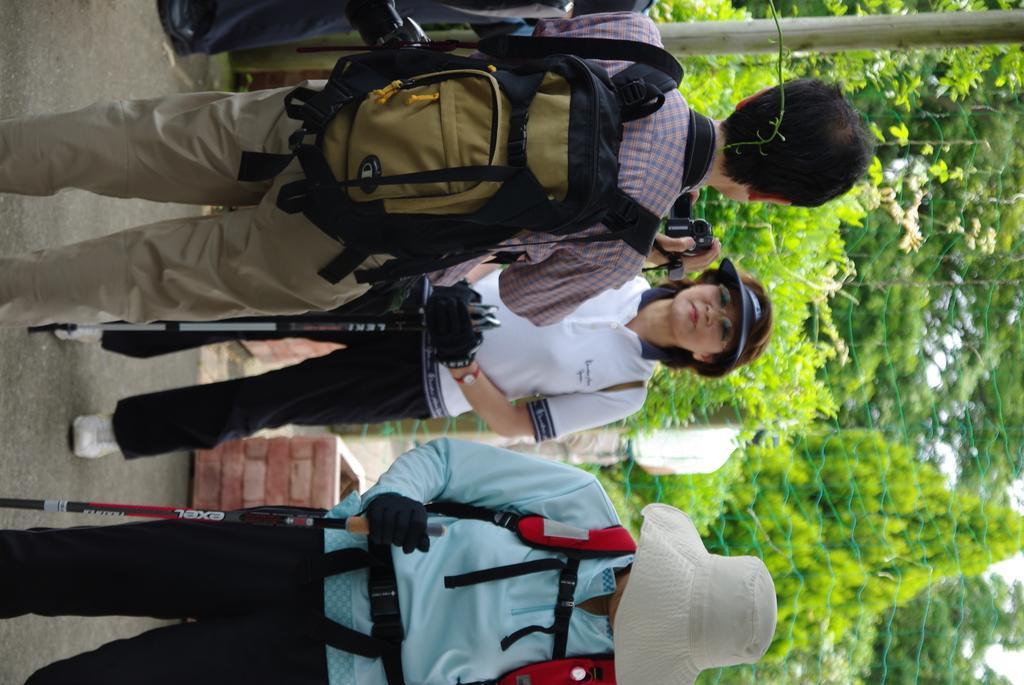Please provide a concise description of this image. In this image, we can see few peoples are standing. Few are smiling. Few are wearing a caps on his head. At the left side, person is wearing a backpack and he hold camera on his hand. The back side, we can see few trees, net and pole. In the middle and right person are holding a stick. 